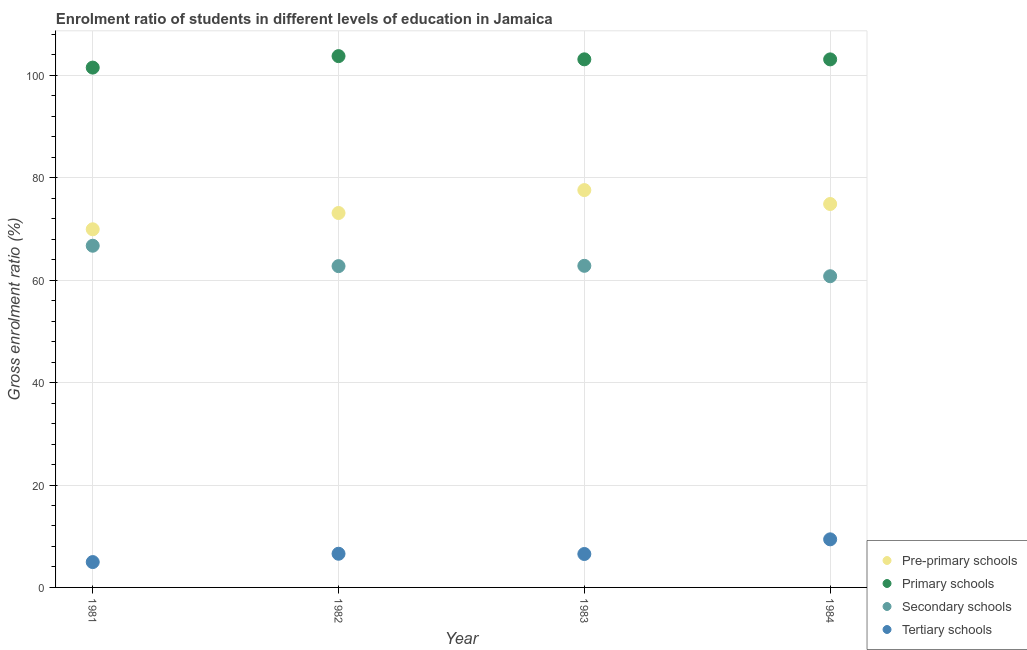What is the gross enrolment ratio in tertiary schools in 1981?
Provide a succinct answer. 4.95. Across all years, what is the maximum gross enrolment ratio in pre-primary schools?
Keep it short and to the point. 77.6. Across all years, what is the minimum gross enrolment ratio in primary schools?
Your answer should be compact. 101.53. In which year was the gross enrolment ratio in pre-primary schools minimum?
Provide a short and direct response. 1981. What is the total gross enrolment ratio in tertiary schools in the graph?
Offer a terse response. 27.45. What is the difference between the gross enrolment ratio in primary schools in 1981 and that in 1984?
Give a very brief answer. -1.6. What is the difference between the gross enrolment ratio in tertiary schools in 1981 and the gross enrolment ratio in pre-primary schools in 1983?
Your answer should be compact. -72.65. What is the average gross enrolment ratio in secondary schools per year?
Give a very brief answer. 63.27. In the year 1983, what is the difference between the gross enrolment ratio in secondary schools and gross enrolment ratio in primary schools?
Your answer should be compact. -40.33. What is the ratio of the gross enrolment ratio in tertiary schools in 1981 to that in 1982?
Ensure brevity in your answer.  0.75. What is the difference between the highest and the second highest gross enrolment ratio in pre-primary schools?
Your response must be concise. 2.72. What is the difference between the highest and the lowest gross enrolment ratio in tertiary schools?
Your answer should be very brief. 4.44. Is it the case that in every year, the sum of the gross enrolment ratio in pre-primary schools and gross enrolment ratio in primary schools is greater than the gross enrolment ratio in secondary schools?
Your answer should be compact. Yes. Is the gross enrolment ratio in pre-primary schools strictly greater than the gross enrolment ratio in tertiary schools over the years?
Ensure brevity in your answer.  Yes. How many dotlines are there?
Give a very brief answer. 4. How many years are there in the graph?
Your response must be concise. 4. What is the difference between two consecutive major ticks on the Y-axis?
Offer a very short reply. 20. Where does the legend appear in the graph?
Your answer should be very brief. Bottom right. What is the title of the graph?
Provide a succinct answer. Enrolment ratio of students in different levels of education in Jamaica. What is the label or title of the Y-axis?
Keep it short and to the point. Gross enrolment ratio (%). What is the Gross enrolment ratio (%) in Pre-primary schools in 1981?
Provide a succinct answer. 69.95. What is the Gross enrolment ratio (%) of Primary schools in 1981?
Ensure brevity in your answer.  101.53. What is the Gross enrolment ratio (%) of Secondary schools in 1981?
Make the answer very short. 66.74. What is the Gross enrolment ratio (%) in Tertiary schools in 1981?
Provide a short and direct response. 4.95. What is the Gross enrolment ratio (%) in Pre-primary schools in 1982?
Ensure brevity in your answer.  73.13. What is the Gross enrolment ratio (%) of Primary schools in 1982?
Your answer should be very brief. 103.77. What is the Gross enrolment ratio (%) in Secondary schools in 1982?
Ensure brevity in your answer.  62.75. What is the Gross enrolment ratio (%) in Tertiary schools in 1982?
Your answer should be very brief. 6.58. What is the Gross enrolment ratio (%) in Pre-primary schools in 1983?
Offer a terse response. 77.6. What is the Gross enrolment ratio (%) in Primary schools in 1983?
Offer a very short reply. 103.14. What is the Gross enrolment ratio (%) of Secondary schools in 1983?
Offer a terse response. 62.81. What is the Gross enrolment ratio (%) in Tertiary schools in 1983?
Your response must be concise. 6.53. What is the Gross enrolment ratio (%) in Pre-primary schools in 1984?
Give a very brief answer. 74.89. What is the Gross enrolment ratio (%) of Primary schools in 1984?
Make the answer very short. 103.13. What is the Gross enrolment ratio (%) of Secondary schools in 1984?
Ensure brevity in your answer.  60.78. What is the Gross enrolment ratio (%) of Tertiary schools in 1984?
Make the answer very short. 9.39. Across all years, what is the maximum Gross enrolment ratio (%) in Pre-primary schools?
Provide a short and direct response. 77.6. Across all years, what is the maximum Gross enrolment ratio (%) of Primary schools?
Keep it short and to the point. 103.77. Across all years, what is the maximum Gross enrolment ratio (%) in Secondary schools?
Your answer should be very brief. 66.74. Across all years, what is the maximum Gross enrolment ratio (%) of Tertiary schools?
Provide a short and direct response. 9.39. Across all years, what is the minimum Gross enrolment ratio (%) of Pre-primary schools?
Ensure brevity in your answer.  69.95. Across all years, what is the minimum Gross enrolment ratio (%) in Primary schools?
Offer a terse response. 101.53. Across all years, what is the minimum Gross enrolment ratio (%) of Secondary schools?
Provide a short and direct response. 60.78. Across all years, what is the minimum Gross enrolment ratio (%) in Tertiary schools?
Make the answer very short. 4.95. What is the total Gross enrolment ratio (%) in Pre-primary schools in the graph?
Ensure brevity in your answer.  295.57. What is the total Gross enrolment ratio (%) of Primary schools in the graph?
Provide a short and direct response. 411.58. What is the total Gross enrolment ratio (%) in Secondary schools in the graph?
Keep it short and to the point. 253.08. What is the total Gross enrolment ratio (%) of Tertiary schools in the graph?
Your response must be concise. 27.45. What is the difference between the Gross enrolment ratio (%) of Pre-primary schools in 1981 and that in 1982?
Offer a terse response. -3.18. What is the difference between the Gross enrolment ratio (%) of Primary schools in 1981 and that in 1982?
Provide a short and direct response. -2.24. What is the difference between the Gross enrolment ratio (%) in Secondary schools in 1981 and that in 1982?
Provide a short and direct response. 3.98. What is the difference between the Gross enrolment ratio (%) in Tertiary schools in 1981 and that in 1982?
Give a very brief answer. -1.62. What is the difference between the Gross enrolment ratio (%) in Pre-primary schools in 1981 and that in 1983?
Ensure brevity in your answer.  -7.66. What is the difference between the Gross enrolment ratio (%) of Primary schools in 1981 and that in 1983?
Provide a short and direct response. -1.61. What is the difference between the Gross enrolment ratio (%) in Secondary schools in 1981 and that in 1983?
Your response must be concise. 3.92. What is the difference between the Gross enrolment ratio (%) of Tertiary schools in 1981 and that in 1983?
Give a very brief answer. -1.58. What is the difference between the Gross enrolment ratio (%) in Pre-primary schools in 1981 and that in 1984?
Provide a succinct answer. -4.94. What is the difference between the Gross enrolment ratio (%) in Primary schools in 1981 and that in 1984?
Make the answer very short. -1.6. What is the difference between the Gross enrolment ratio (%) of Secondary schools in 1981 and that in 1984?
Give a very brief answer. 5.96. What is the difference between the Gross enrolment ratio (%) in Tertiary schools in 1981 and that in 1984?
Make the answer very short. -4.44. What is the difference between the Gross enrolment ratio (%) of Pre-primary schools in 1982 and that in 1983?
Ensure brevity in your answer.  -4.48. What is the difference between the Gross enrolment ratio (%) of Primary schools in 1982 and that in 1983?
Ensure brevity in your answer.  0.63. What is the difference between the Gross enrolment ratio (%) of Secondary schools in 1982 and that in 1983?
Your response must be concise. -0.06. What is the difference between the Gross enrolment ratio (%) of Tertiary schools in 1982 and that in 1983?
Keep it short and to the point. 0.05. What is the difference between the Gross enrolment ratio (%) in Pre-primary schools in 1982 and that in 1984?
Provide a succinct answer. -1.76. What is the difference between the Gross enrolment ratio (%) in Primary schools in 1982 and that in 1984?
Give a very brief answer. 0.64. What is the difference between the Gross enrolment ratio (%) of Secondary schools in 1982 and that in 1984?
Offer a terse response. 1.97. What is the difference between the Gross enrolment ratio (%) of Tertiary schools in 1982 and that in 1984?
Your answer should be compact. -2.81. What is the difference between the Gross enrolment ratio (%) in Pre-primary schools in 1983 and that in 1984?
Your answer should be compact. 2.72. What is the difference between the Gross enrolment ratio (%) of Primary schools in 1983 and that in 1984?
Provide a short and direct response. 0.01. What is the difference between the Gross enrolment ratio (%) of Secondary schools in 1983 and that in 1984?
Provide a succinct answer. 2.03. What is the difference between the Gross enrolment ratio (%) of Tertiary schools in 1983 and that in 1984?
Offer a very short reply. -2.86. What is the difference between the Gross enrolment ratio (%) of Pre-primary schools in 1981 and the Gross enrolment ratio (%) of Primary schools in 1982?
Make the answer very short. -33.82. What is the difference between the Gross enrolment ratio (%) of Pre-primary schools in 1981 and the Gross enrolment ratio (%) of Secondary schools in 1982?
Your answer should be very brief. 7.2. What is the difference between the Gross enrolment ratio (%) of Pre-primary schools in 1981 and the Gross enrolment ratio (%) of Tertiary schools in 1982?
Offer a terse response. 63.37. What is the difference between the Gross enrolment ratio (%) of Primary schools in 1981 and the Gross enrolment ratio (%) of Secondary schools in 1982?
Ensure brevity in your answer.  38.78. What is the difference between the Gross enrolment ratio (%) in Primary schools in 1981 and the Gross enrolment ratio (%) in Tertiary schools in 1982?
Provide a short and direct response. 94.95. What is the difference between the Gross enrolment ratio (%) of Secondary schools in 1981 and the Gross enrolment ratio (%) of Tertiary schools in 1982?
Provide a short and direct response. 60.16. What is the difference between the Gross enrolment ratio (%) of Pre-primary schools in 1981 and the Gross enrolment ratio (%) of Primary schools in 1983?
Ensure brevity in your answer.  -33.2. What is the difference between the Gross enrolment ratio (%) of Pre-primary schools in 1981 and the Gross enrolment ratio (%) of Secondary schools in 1983?
Your answer should be very brief. 7.14. What is the difference between the Gross enrolment ratio (%) in Pre-primary schools in 1981 and the Gross enrolment ratio (%) in Tertiary schools in 1983?
Keep it short and to the point. 63.42. What is the difference between the Gross enrolment ratio (%) in Primary schools in 1981 and the Gross enrolment ratio (%) in Secondary schools in 1983?
Offer a very short reply. 38.72. What is the difference between the Gross enrolment ratio (%) of Primary schools in 1981 and the Gross enrolment ratio (%) of Tertiary schools in 1983?
Your answer should be compact. 95. What is the difference between the Gross enrolment ratio (%) of Secondary schools in 1981 and the Gross enrolment ratio (%) of Tertiary schools in 1983?
Keep it short and to the point. 60.21. What is the difference between the Gross enrolment ratio (%) of Pre-primary schools in 1981 and the Gross enrolment ratio (%) of Primary schools in 1984?
Give a very brief answer. -33.18. What is the difference between the Gross enrolment ratio (%) in Pre-primary schools in 1981 and the Gross enrolment ratio (%) in Secondary schools in 1984?
Ensure brevity in your answer.  9.17. What is the difference between the Gross enrolment ratio (%) of Pre-primary schools in 1981 and the Gross enrolment ratio (%) of Tertiary schools in 1984?
Your answer should be very brief. 60.56. What is the difference between the Gross enrolment ratio (%) of Primary schools in 1981 and the Gross enrolment ratio (%) of Secondary schools in 1984?
Make the answer very short. 40.75. What is the difference between the Gross enrolment ratio (%) of Primary schools in 1981 and the Gross enrolment ratio (%) of Tertiary schools in 1984?
Offer a terse response. 92.14. What is the difference between the Gross enrolment ratio (%) of Secondary schools in 1981 and the Gross enrolment ratio (%) of Tertiary schools in 1984?
Make the answer very short. 57.34. What is the difference between the Gross enrolment ratio (%) in Pre-primary schools in 1982 and the Gross enrolment ratio (%) in Primary schools in 1983?
Keep it short and to the point. -30.01. What is the difference between the Gross enrolment ratio (%) of Pre-primary schools in 1982 and the Gross enrolment ratio (%) of Secondary schools in 1983?
Your answer should be very brief. 10.32. What is the difference between the Gross enrolment ratio (%) of Pre-primary schools in 1982 and the Gross enrolment ratio (%) of Tertiary schools in 1983?
Give a very brief answer. 66.6. What is the difference between the Gross enrolment ratio (%) in Primary schools in 1982 and the Gross enrolment ratio (%) in Secondary schools in 1983?
Make the answer very short. 40.96. What is the difference between the Gross enrolment ratio (%) of Primary schools in 1982 and the Gross enrolment ratio (%) of Tertiary schools in 1983?
Provide a succinct answer. 97.24. What is the difference between the Gross enrolment ratio (%) in Secondary schools in 1982 and the Gross enrolment ratio (%) in Tertiary schools in 1983?
Your response must be concise. 56.22. What is the difference between the Gross enrolment ratio (%) in Pre-primary schools in 1982 and the Gross enrolment ratio (%) in Primary schools in 1984?
Keep it short and to the point. -30. What is the difference between the Gross enrolment ratio (%) of Pre-primary schools in 1982 and the Gross enrolment ratio (%) of Secondary schools in 1984?
Keep it short and to the point. 12.35. What is the difference between the Gross enrolment ratio (%) of Pre-primary schools in 1982 and the Gross enrolment ratio (%) of Tertiary schools in 1984?
Your response must be concise. 63.74. What is the difference between the Gross enrolment ratio (%) of Primary schools in 1982 and the Gross enrolment ratio (%) of Secondary schools in 1984?
Keep it short and to the point. 42.99. What is the difference between the Gross enrolment ratio (%) of Primary schools in 1982 and the Gross enrolment ratio (%) of Tertiary schools in 1984?
Offer a very short reply. 94.38. What is the difference between the Gross enrolment ratio (%) of Secondary schools in 1982 and the Gross enrolment ratio (%) of Tertiary schools in 1984?
Your response must be concise. 53.36. What is the difference between the Gross enrolment ratio (%) in Pre-primary schools in 1983 and the Gross enrolment ratio (%) in Primary schools in 1984?
Provide a succinct answer. -25.53. What is the difference between the Gross enrolment ratio (%) of Pre-primary schools in 1983 and the Gross enrolment ratio (%) of Secondary schools in 1984?
Your answer should be compact. 16.83. What is the difference between the Gross enrolment ratio (%) in Pre-primary schools in 1983 and the Gross enrolment ratio (%) in Tertiary schools in 1984?
Give a very brief answer. 68.21. What is the difference between the Gross enrolment ratio (%) of Primary schools in 1983 and the Gross enrolment ratio (%) of Secondary schools in 1984?
Your answer should be very brief. 42.36. What is the difference between the Gross enrolment ratio (%) of Primary schools in 1983 and the Gross enrolment ratio (%) of Tertiary schools in 1984?
Offer a terse response. 93.75. What is the difference between the Gross enrolment ratio (%) in Secondary schools in 1983 and the Gross enrolment ratio (%) in Tertiary schools in 1984?
Keep it short and to the point. 53.42. What is the average Gross enrolment ratio (%) of Pre-primary schools per year?
Your answer should be very brief. 73.89. What is the average Gross enrolment ratio (%) in Primary schools per year?
Give a very brief answer. 102.89. What is the average Gross enrolment ratio (%) of Secondary schools per year?
Your answer should be compact. 63.27. What is the average Gross enrolment ratio (%) of Tertiary schools per year?
Your answer should be very brief. 6.86. In the year 1981, what is the difference between the Gross enrolment ratio (%) of Pre-primary schools and Gross enrolment ratio (%) of Primary schools?
Make the answer very short. -31.58. In the year 1981, what is the difference between the Gross enrolment ratio (%) in Pre-primary schools and Gross enrolment ratio (%) in Secondary schools?
Make the answer very short. 3.21. In the year 1981, what is the difference between the Gross enrolment ratio (%) of Pre-primary schools and Gross enrolment ratio (%) of Tertiary schools?
Provide a succinct answer. 65. In the year 1981, what is the difference between the Gross enrolment ratio (%) in Primary schools and Gross enrolment ratio (%) in Secondary schools?
Provide a short and direct response. 34.79. In the year 1981, what is the difference between the Gross enrolment ratio (%) of Primary schools and Gross enrolment ratio (%) of Tertiary schools?
Ensure brevity in your answer.  96.58. In the year 1981, what is the difference between the Gross enrolment ratio (%) of Secondary schools and Gross enrolment ratio (%) of Tertiary schools?
Give a very brief answer. 61.78. In the year 1982, what is the difference between the Gross enrolment ratio (%) in Pre-primary schools and Gross enrolment ratio (%) in Primary schools?
Your answer should be compact. -30.64. In the year 1982, what is the difference between the Gross enrolment ratio (%) of Pre-primary schools and Gross enrolment ratio (%) of Secondary schools?
Ensure brevity in your answer.  10.38. In the year 1982, what is the difference between the Gross enrolment ratio (%) of Pre-primary schools and Gross enrolment ratio (%) of Tertiary schools?
Provide a short and direct response. 66.55. In the year 1982, what is the difference between the Gross enrolment ratio (%) in Primary schools and Gross enrolment ratio (%) in Secondary schools?
Your answer should be compact. 41.02. In the year 1982, what is the difference between the Gross enrolment ratio (%) of Primary schools and Gross enrolment ratio (%) of Tertiary schools?
Provide a short and direct response. 97.19. In the year 1982, what is the difference between the Gross enrolment ratio (%) in Secondary schools and Gross enrolment ratio (%) in Tertiary schools?
Make the answer very short. 56.18. In the year 1983, what is the difference between the Gross enrolment ratio (%) of Pre-primary schools and Gross enrolment ratio (%) of Primary schools?
Offer a very short reply. -25.54. In the year 1983, what is the difference between the Gross enrolment ratio (%) of Pre-primary schools and Gross enrolment ratio (%) of Secondary schools?
Give a very brief answer. 14.79. In the year 1983, what is the difference between the Gross enrolment ratio (%) of Pre-primary schools and Gross enrolment ratio (%) of Tertiary schools?
Offer a terse response. 71.08. In the year 1983, what is the difference between the Gross enrolment ratio (%) of Primary schools and Gross enrolment ratio (%) of Secondary schools?
Provide a succinct answer. 40.33. In the year 1983, what is the difference between the Gross enrolment ratio (%) in Primary schools and Gross enrolment ratio (%) in Tertiary schools?
Give a very brief answer. 96.61. In the year 1983, what is the difference between the Gross enrolment ratio (%) in Secondary schools and Gross enrolment ratio (%) in Tertiary schools?
Offer a very short reply. 56.28. In the year 1984, what is the difference between the Gross enrolment ratio (%) of Pre-primary schools and Gross enrolment ratio (%) of Primary schools?
Your answer should be very brief. -28.24. In the year 1984, what is the difference between the Gross enrolment ratio (%) in Pre-primary schools and Gross enrolment ratio (%) in Secondary schools?
Keep it short and to the point. 14.11. In the year 1984, what is the difference between the Gross enrolment ratio (%) of Pre-primary schools and Gross enrolment ratio (%) of Tertiary schools?
Provide a succinct answer. 65.5. In the year 1984, what is the difference between the Gross enrolment ratio (%) of Primary schools and Gross enrolment ratio (%) of Secondary schools?
Offer a terse response. 42.35. In the year 1984, what is the difference between the Gross enrolment ratio (%) in Primary schools and Gross enrolment ratio (%) in Tertiary schools?
Provide a short and direct response. 93.74. In the year 1984, what is the difference between the Gross enrolment ratio (%) of Secondary schools and Gross enrolment ratio (%) of Tertiary schools?
Provide a succinct answer. 51.39. What is the ratio of the Gross enrolment ratio (%) of Pre-primary schools in 1981 to that in 1982?
Give a very brief answer. 0.96. What is the ratio of the Gross enrolment ratio (%) in Primary schools in 1981 to that in 1982?
Give a very brief answer. 0.98. What is the ratio of the Gross enrolment ratio (%) in Secondary schools in 1981 to that in 1982?
Offer a very short reply. 1.06. What is the ratio of the Gross enrolment ratio (%) of Tertiary schools in 1981 to that in 1982?
Provide a succinct answer. 0.75. What is the ratio of the Gross enrolment ratio (%) of Pre-primary schools in 1981 to that in 1983?
Keep it short and to the point. 0.9. What is the ratio of the Gross enrolment ratio (%) in Primary schools in 1981 to that in 1983?
Your response must be concise. 0.98. What is the ratio of the Gross enrolment ratio (%) of Secondary schools in 1981 to that in 1983?
Your response must be concise. 1.06. What is the ratio of the Gross enrolment ratio (%) in Tertiary schools in 1981 to that in 1983?
Your answer should be compact. 0.76. What is the ratio of the Gross enrolment ratio (%) in Pre-primary schools in 1981 to that in 1984?
Provide a succinct answer. 0.93. What is the ratio of the Gross enrolment ratio (%) in Primary schools in 1981 to that in 1984?
Give a very brief answer. 0.98. What is the ratio of the Gross enrolment ratio (%) of Secondary schools in 1981 to that in 1984?
Ensure brevity in your answer.  1.1. What is the ratio of the Gross enrolment ratio (%) in Tertiary schools in 1981 to that in 1984?
Offer a terse response. 0.53. What is the ratio of the Gross enrolment ratio (%) in Pre-primary schools in 1982 to that in 1983?
Offer a terse response. 0.94. What is the ratio of the Gross enrolment ratio (%) in Primary schools in 1982 to that in 1983?
Make the answer very short. 1.01. What is the ratio of the Gross enrolment ratio (%) of Tertiary schools in 1982 to that in 1983?
Give a very brief answer. 1.01. What is the ratio of the Gross enrolment ratio (%) in Pre-primary schools in 1982 to that in 1984?
Ensure brevity in your answer.  0.98. What is the ratio of the Gross enrolment ratio (%) in Primary schools in 1982 to that in 1984?
Make the answer very short. 1.01. What is the ratio of the Gross enrolment ratio (%) in Secondary schools in 1982 to that in 1984?
Provide a succinct answer. 1.03. What is the ratio of the Gross enrolment ratio (%) in Tertiary schools in 1982 to that in 1984?
Keep it short and to the point. 0.7. What is the ratio of the Gross enrolment ratio (%) in Pre-primary schools in 1983 to that in 1984?
Your response must be concise. 1.04. What is the ratio of the Gross enrolment ratio (%) of Secondary schools in 1983 to that in 1984?
Your answer should be compact. 1.03. What is the ratio of the Gross enrolment ratio (%) of Tertiary schools in 1983 to that in 1984?
Your answer should be very brief. 0.7. What is the difference between the highest and the second highest Gross enrolment ratio (%) in Pre-primary schools?
Keep it short and to the point. 2.72. What is the difference between the highest and the second highest Gross enrolment ratio (%) of Primary schools?
Give a very brief answer. 0.63. What is the difference between the highest and the second highest Gross enrolment ratio (%) of Secondary schools?
Make the answer very short. 3.92. What is the difference between the highest and the second highest Gross enrolment ratio (%) in Tertiary schools?
Offer a very short reply. 2.81. What is the difference between the highest and the lowest Gross enrolment ratio (%) in Pre-primary schools?
Offer a terse response. 7.66. What is the difference between the highest and the lowest Gross enrolment ratio (%) in Primary schools?
Your answer should be very brief. 2.24. What is the difference between the highest and the lowest Gross enrolment ratio (%) in Secondary schools?
Your answer should be compact. 5.96. What is the difference between the highest and the lowest Gross enrolment ratio (%) of Tertiary schools?
Your response must be concise. 4.44. 